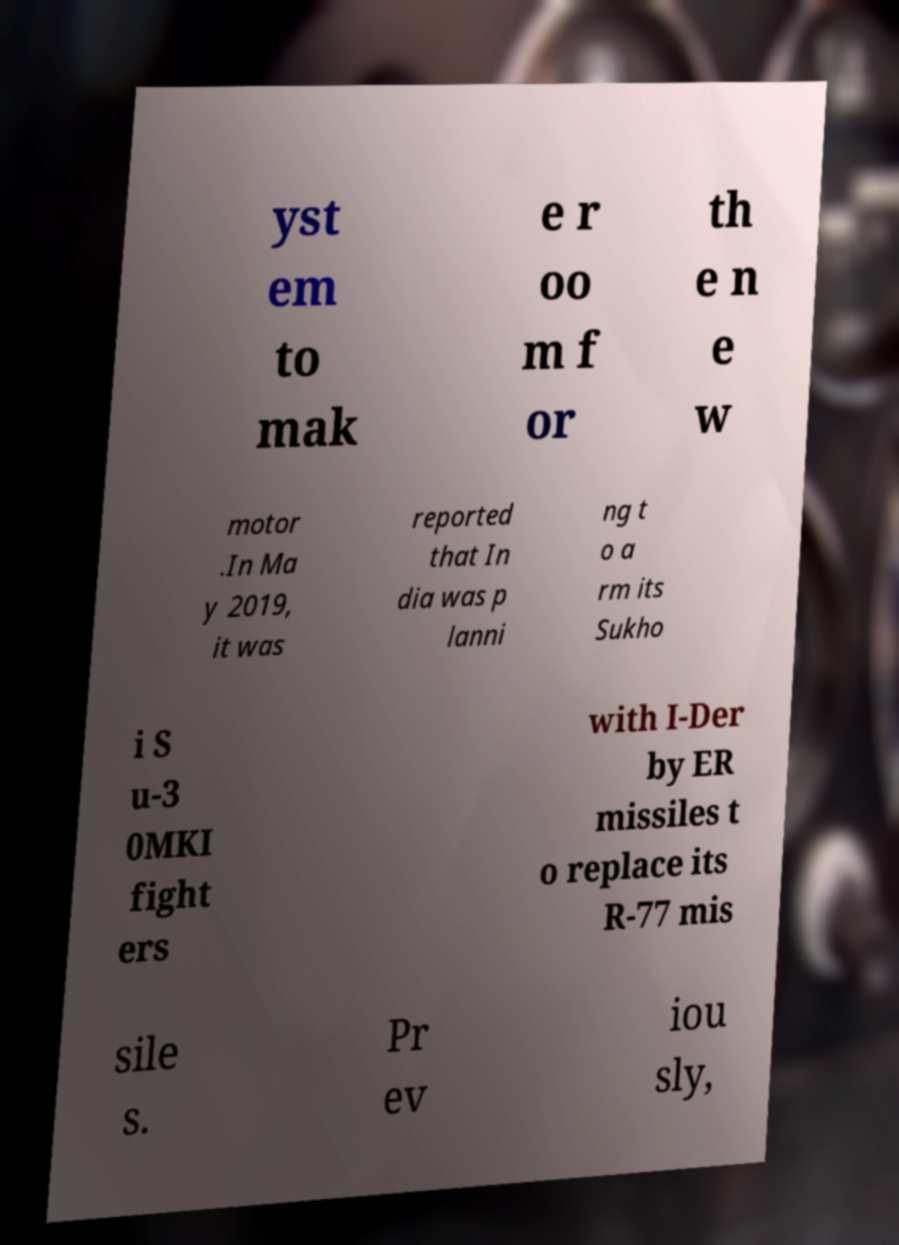Can you accurately transcribe the text from the provided image for me? yst em to mak e r oo m f or th e n e w motor .In Ma y 2019, it was reported that In dia was p lanni ng t o a rm its Sukho i S u-3 0MKI fight ers with I-Der by ER missiles t o replace its R-77 mis sile s. Pr ev iou sly, 